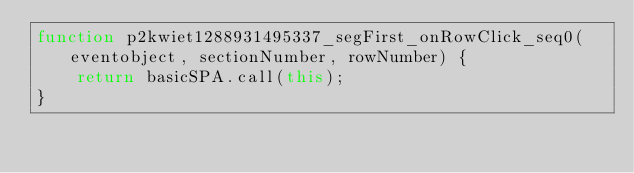<code> <loc_0><loc_0><loc_500><loc_500><_JavaScript_>function p2kwiet1288931495337_segFirst_onRowClick_seq0(eventobject, sectionNumber, rowNumber) {
    return basicSPA.call(this);
}</code> 